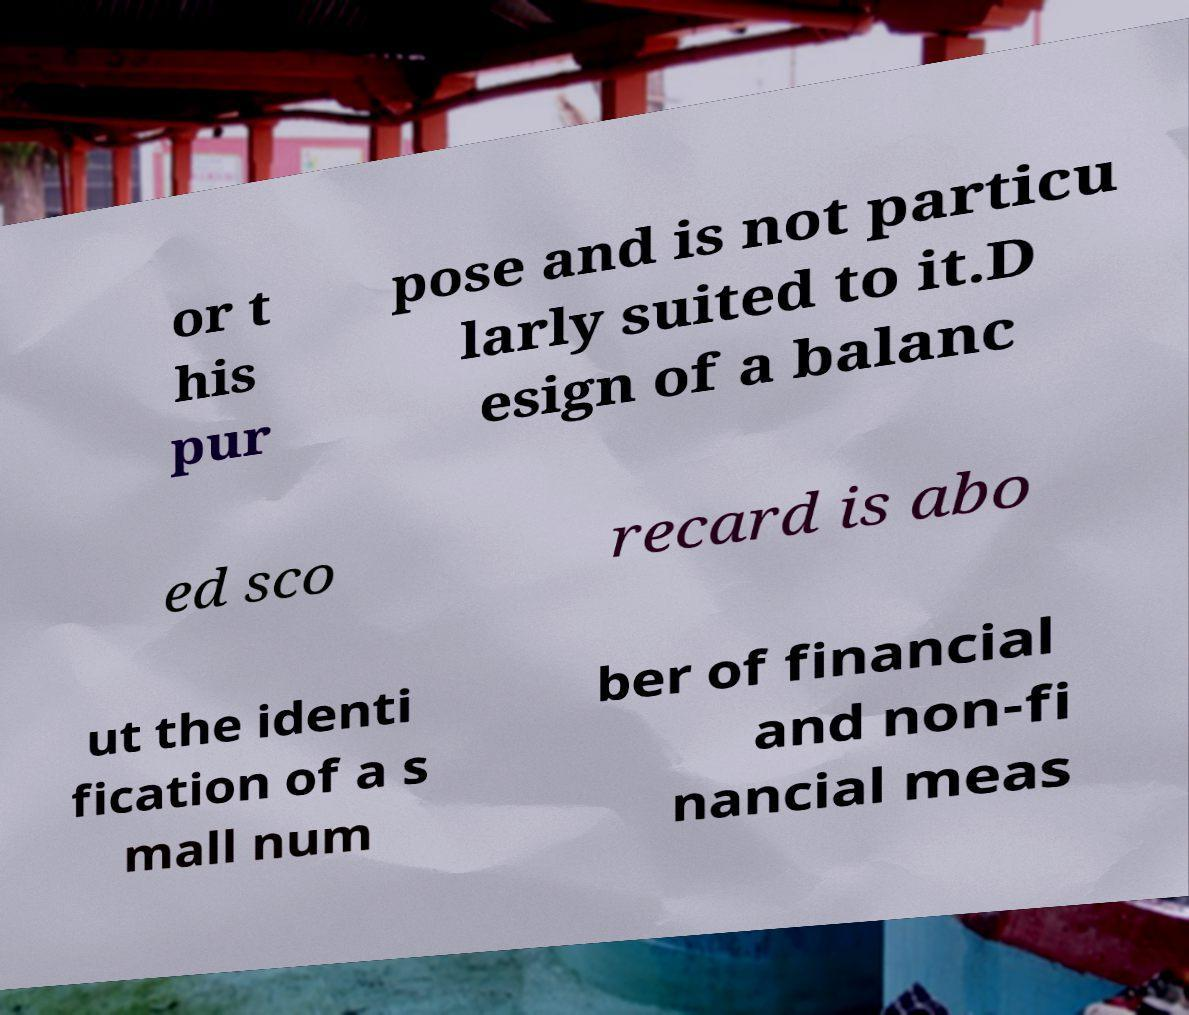I need the written content from this picture converted into text. Can you do that? or t his pur pose and is not particu larly suited to it.D esign of a balanc ed sco recard is abo ut the identi fication of a s mall num ber of financial and non-fi nancial meas 